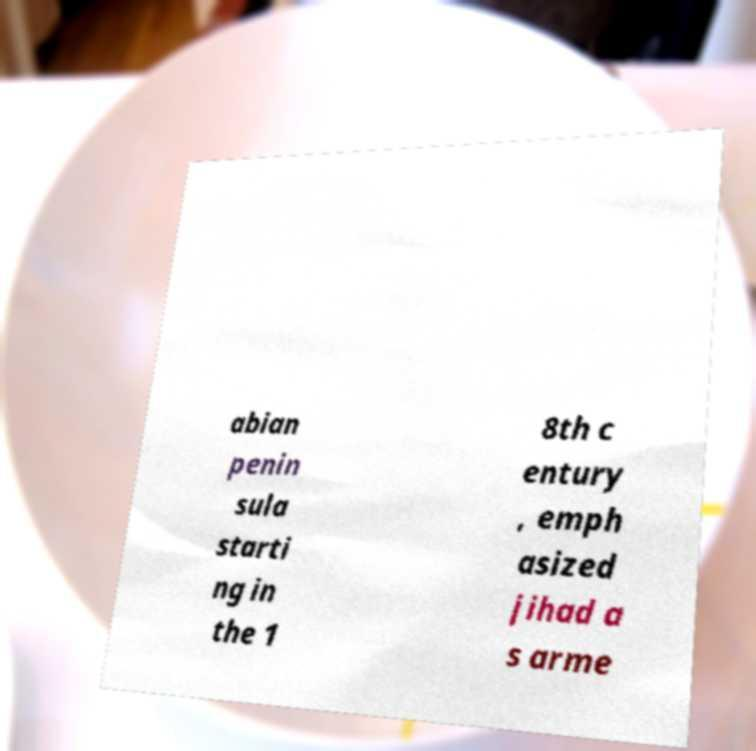There's text embedded in this image that I need extracted. Can you transcribe it verbatim? abian penin sula starti ng in the 1 8th c entury , emph asized jihad a s arme 